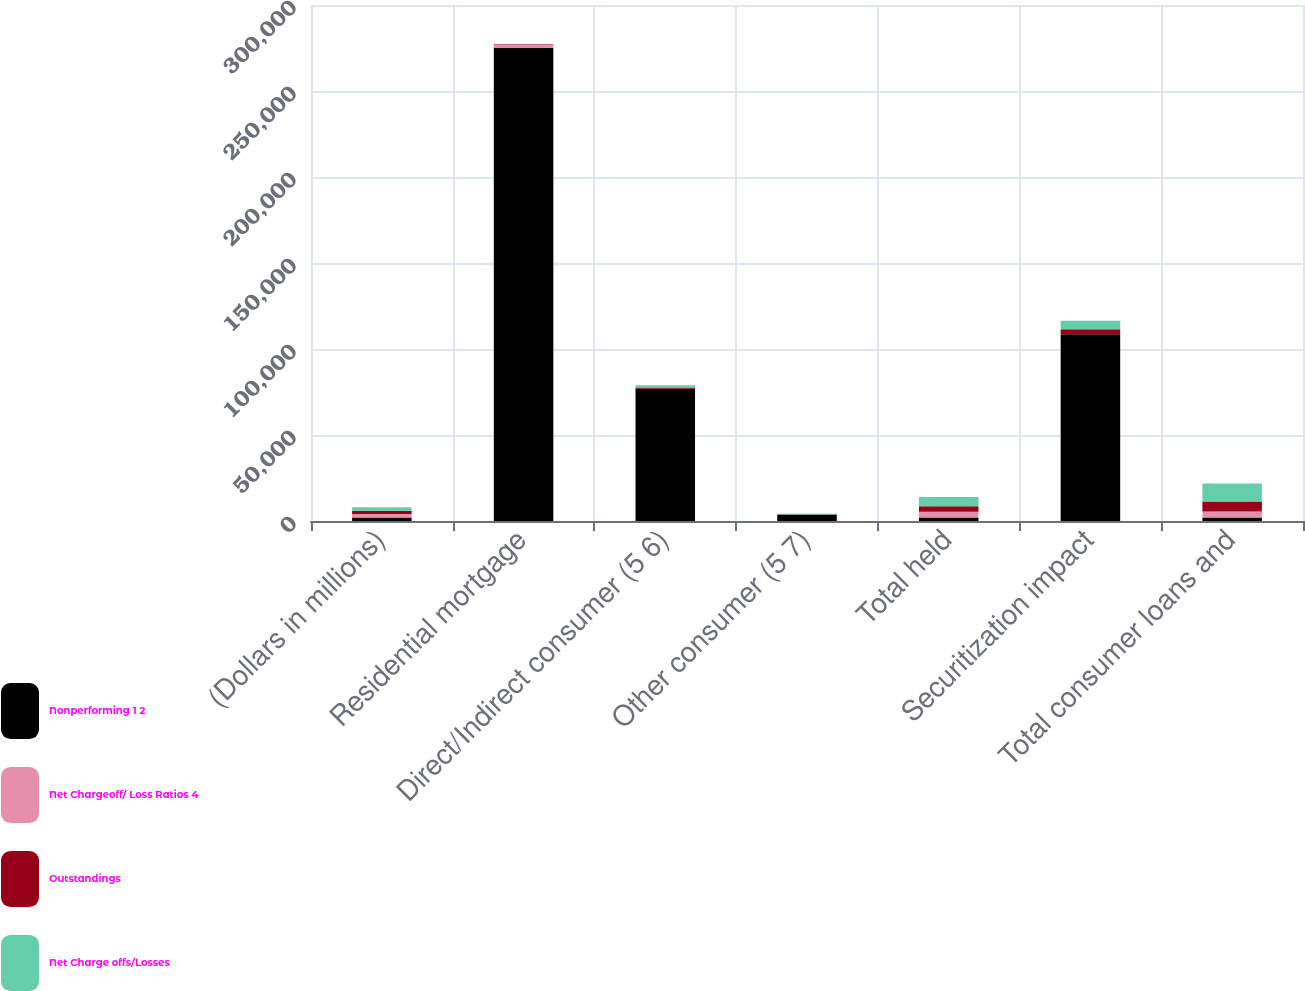Convert chart to OTSL. <chart><loc_0><loc_0><loc_500><loc_500><stacked_bar_chart><ecel><fcel>(Dollars in millions)<fcel>Residential mortgage<fcel>Direct/Indirect consumer (5 6)<fcel>Other consumer (5 7)<fcel>Total held<fcel>Securitization impact<fcel>Total consumer loans and<nl><fcel>Nonperforming 1 2<fcel>2007<fcel>274949<fcel>76844<fcel>3850<fcel>2007<fcel>108646<fcel>2007<nl><fcel>Net Chargeoff/ Loss Ratios 4<fcel>2007<fcel>1999<fcel>8<fcel>95<fcel>3442<fcel>2<fcel>3444<nl><fcel>Outstandings<fcel>2007<fcel>237<fcel>745<fcel>4<fcel>3113<fcel>2764<fcel>5877<nl><fcel>Net Charge offs/Losses<fcel>2007<fcel>57<fcel>1373<fcel>278<fcel>5423<fcel>5003<fcel>10426<nl></chart> 